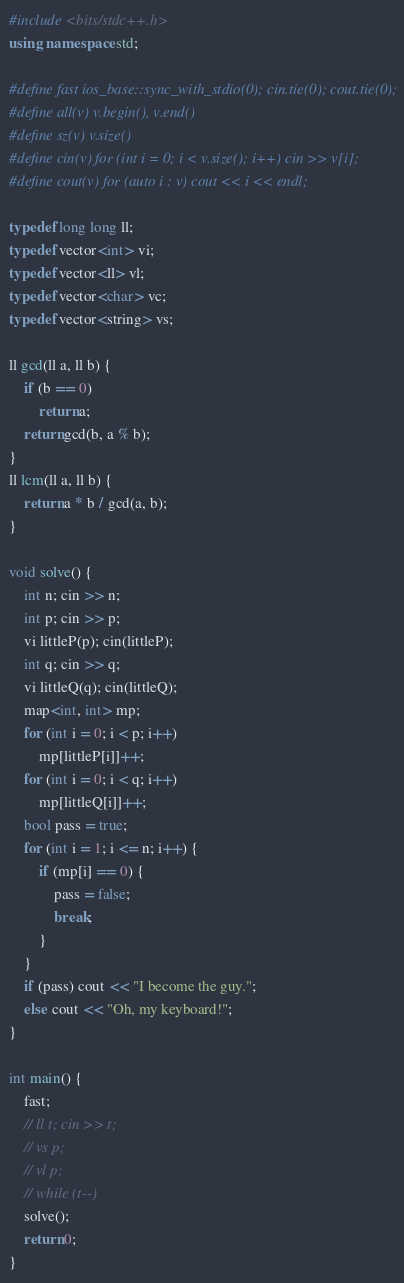Convert code to text. <code><loc_0><loc_0><loc_500><loc_500><_C++_>#include <bits/stdc++.h>
using namespace std;

#define fast ios_base::sync_with_stdio(0); cin.tie(0); cout.tie(0);
#define all(v) v.begin(), v.end()
#define sz(v) v.size()
#define cin(v) for (int i = 0; i < v.size(); i++) cin >> v[i];
#define cout(v) for (auto i : v) cout << i << endl;

typedef long long ll;
typedef vector<int> vi;
typedef vector<ll> vl;
typedef vector<char> vc;
typedef vector<string> vs;

ll gcd(ll a, ll b) {
	if (b == 0)
		return a;
	return gcd(b, a % b);
}
ll lcm(ll a, ll b) {
	return a * b / gcd(a, b);
}

void solve() {
	int n; cin >> n;
	int p; cin >> p;
	vi littleP(p); cin(littleP);
	int q; cin >> q;
	vi littleQ(q); cin(littleQ);
	map<int, int> mp;
	for (int i = 0; i < p; i++)
		mp[littleP[i]]++;
	for (int i = 0; i < q; i++)
		mp[littleQ[i]]++;
	bool pass = true;
	for (int i = 1; i <= n; i++) {
		if (mp[i] == 0) {
			pass = false;
			break;
		}
	}
	if (pass) cout << "I become the guy.";
	else cout << "Oh, my keyboard!";
}

int main() {
	fast;
	// ll t; cin >> t;
	// vs p;
	// vl p;
	// while (t--)
	solve();
	return 0;
}</code> 